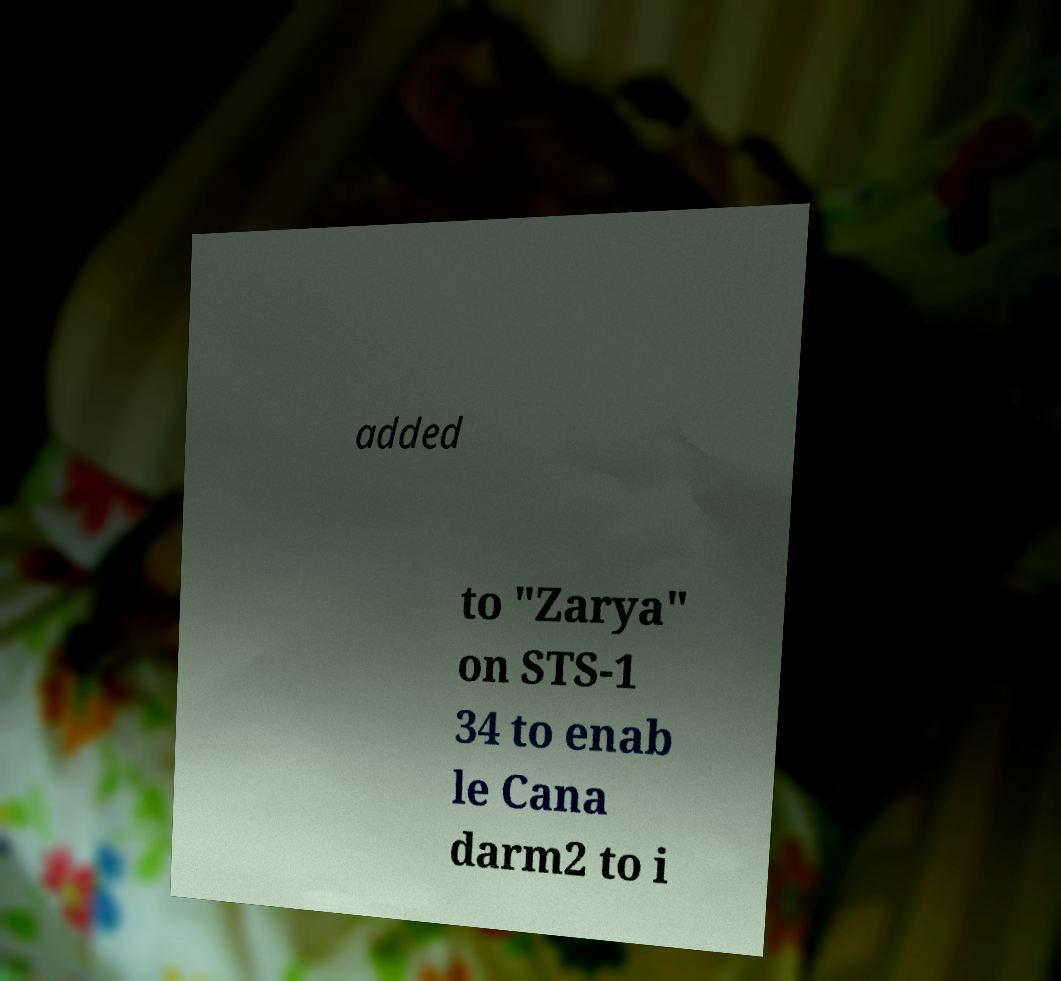For documentation purposes, I need the text within this image transcribed. Could you provide that? added to "Zarya" on STS-1 34 to enab le Cana darm2 to i 